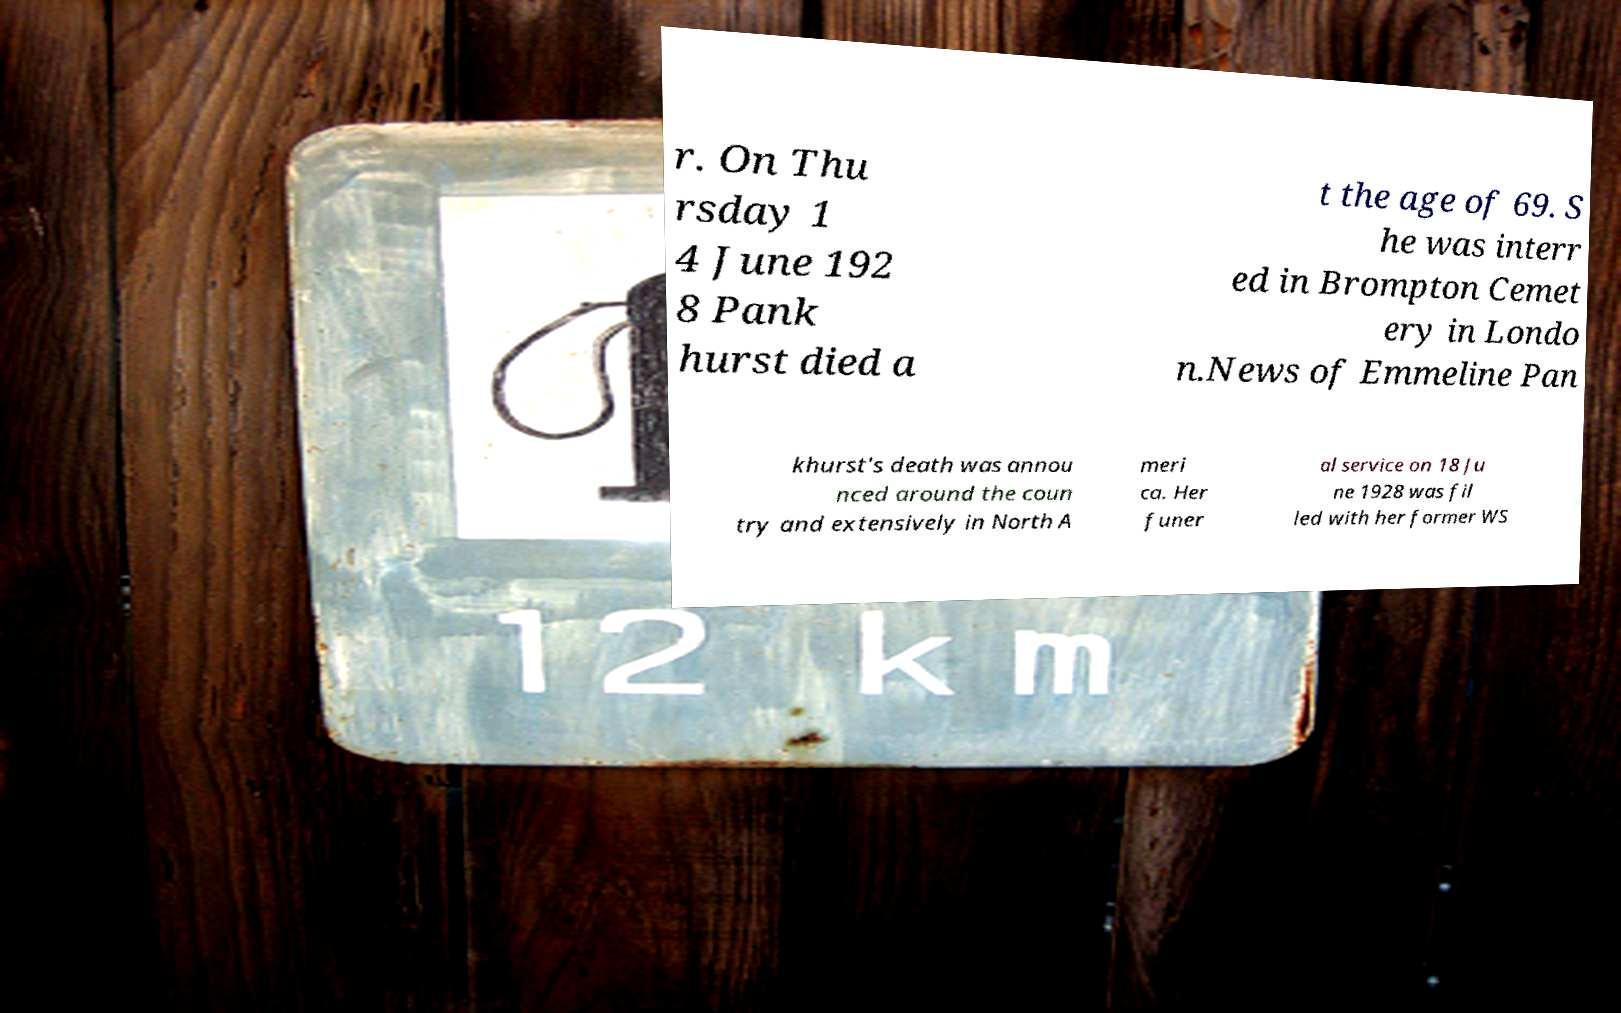What messages or text are displayed in this image? I need them in a readable, typed format. r. On Thu rsday 1 4 June 192 8 Pank hurst died a t the age of 69. S he was interr ed in Brompton Cemet ery in Londo n.News of Emmeline Pan khurst's death was annou nced around the coun try and extensively in North A meri ca. Her funer al service on 18 Ju ne 1928 was fil led with her former WS 